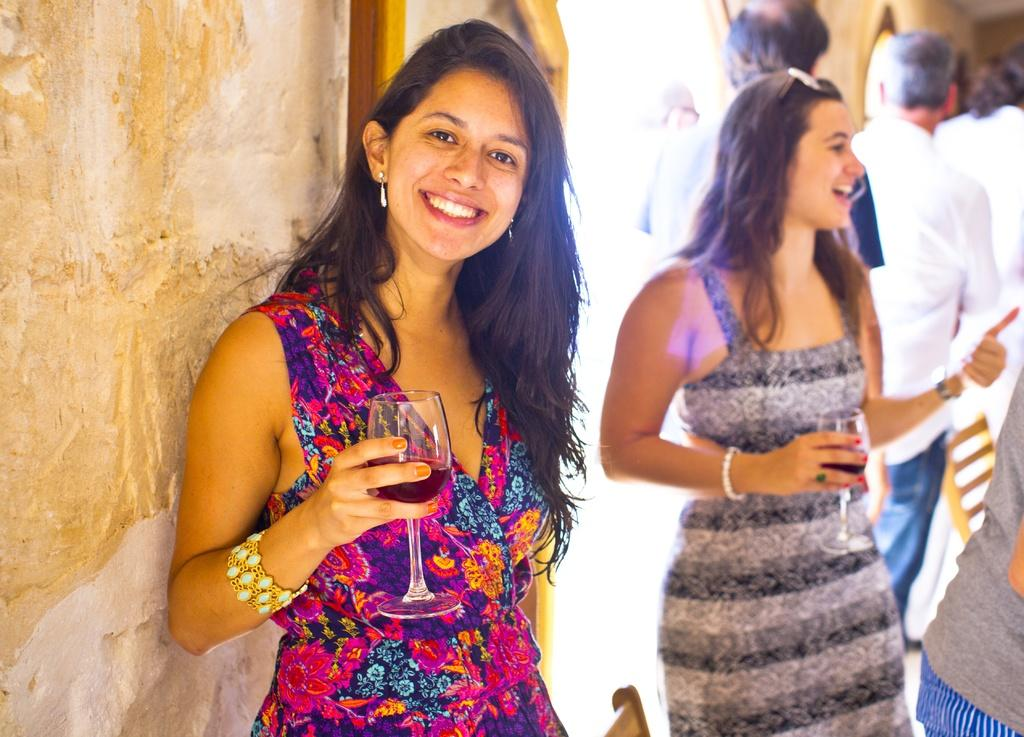Who or what can be seen in the image? There are people in the image. What is located on the left side of the image? There is a wall on the left side of the image. What type of jelly can be seen on the wall in the image? There is no jelly present on the wall in the image. What division of labor is depicted in the image? The image does not show any division of labor; it simply features people and a wall. What crime is being committed in the image? There is no crime being committed in the image; it is a simple scene with people and a wall. 